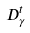<formula> <loc_0><loc_0><loc_500><loc_500>D _ { \gamma } ^ { t }</formula> 